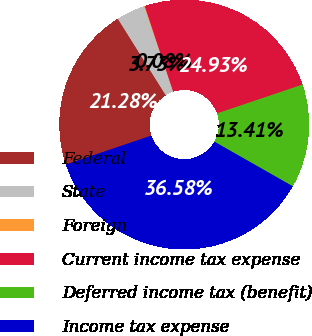Convert chart to OTSL. <chart><loc_0><loc_0><loc_500><loc_500><pie_chart><fcel>Federal<fcel>State<fcel>Foreign<fcel>Current income tax expense<fcel>Deferred income tax (benefit)<fcel>Income tax expense<nl><fcel>21.28%<fcel>3.73%<fcel>0.08%<fcel>24.93%<fcel>13.41%<fcel>36.58%<nl></chart> 